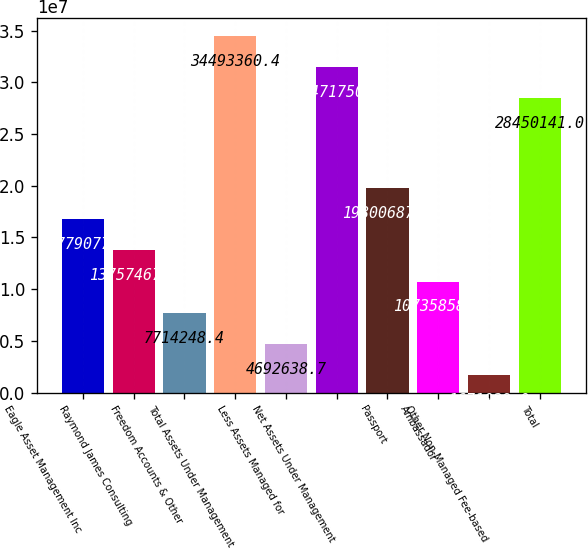<chart> <loc_0><loc_0><loc_500><loc_500><bar_chart><fcel>Eagle Asset Management Inc<fcel>Raymond James Consulting<fcel>Freedom Accounts & Other<fcel>Total Assets Under Management<fcel>Less Assets Managed for<fcel>Net Assets Under Management<fcel>Passport<fcel>Ambassador<fcel>Other Non-Managed Fee-based<fcel>Total<nl><fcel>1.67791e+07<fcel>1.37575e+07<fcel>7.71425e+06<fcel>3.44934e+07<fcel>4.69264e+06<fcel>3.14718e+07<fcel>1.98007e+07<fcel>1.07359e+07<fcel>1.67103e+06<fcel>2.84501e+07<nl></chart> 